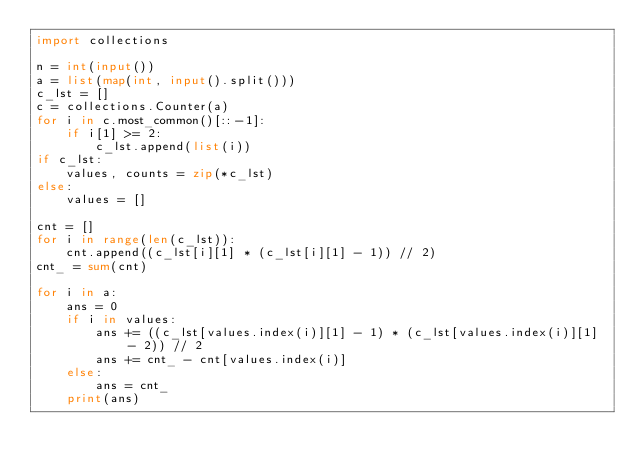<code> <loc_0><loc_0><loc_500><loc_500><_Python_>import collections

n = int(input())
a = list(map(int, input().split()))
c_lst = []
c = collections.Counter(a)
for i in c.most_common()[::-1]:
    if i[1] >= 2:
        c_lst.append(list(i))
if c_lst:
    values, counts = zip(*c_lst)
else:
    values = []

cnt = []
for i in range(len(c_lst)):
    cnt.append((c_lst[i][1] * (c_lst[i][1] - 1)) // 2)
cnt_ = sum(cnt)
    
for i in a:
    ans = 0
    if i in values:
        ans += ((c_lst[values.index(i)][1] - 1) * (c_lst[values.index(i)][1] - 2)) // 2
        ans += cnt_ - cnt[values.index(i)]
    else:
        ans = cnt_
    print(ans)</code> 